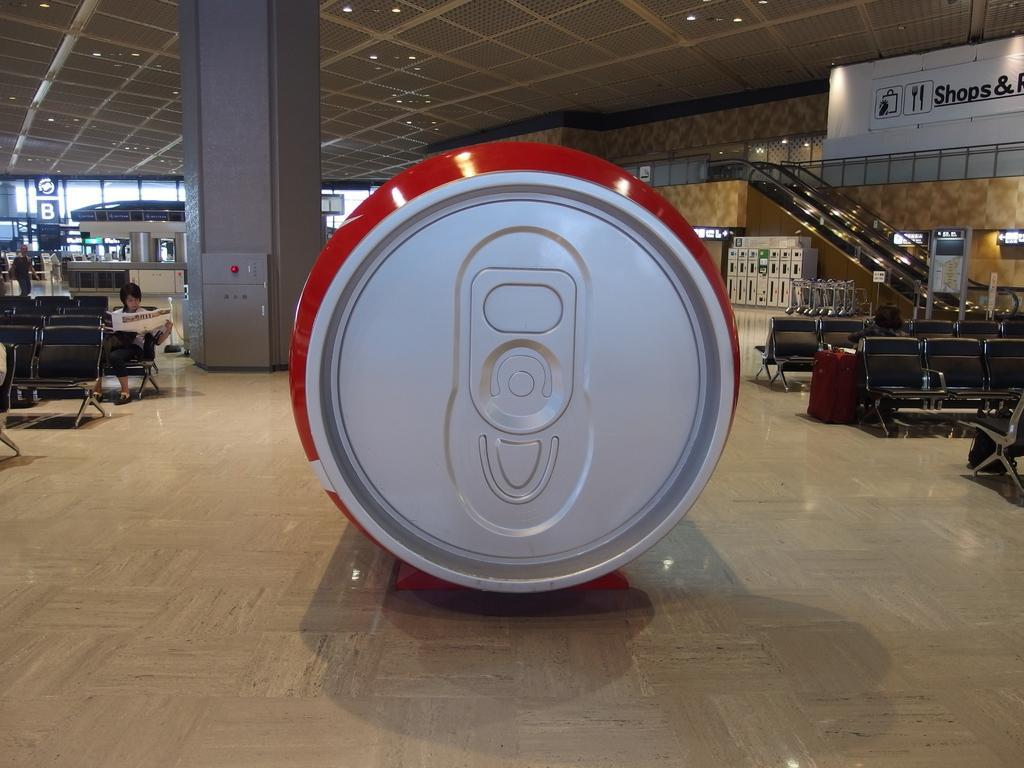Please provide a concise description of this image. In this picture we can see a tin on the floor, chairs, suitcase, woman holding a paper with her hands, pillars, escalators, stand, banner, walls, lights and in the background we can see some objects and a person walking. 